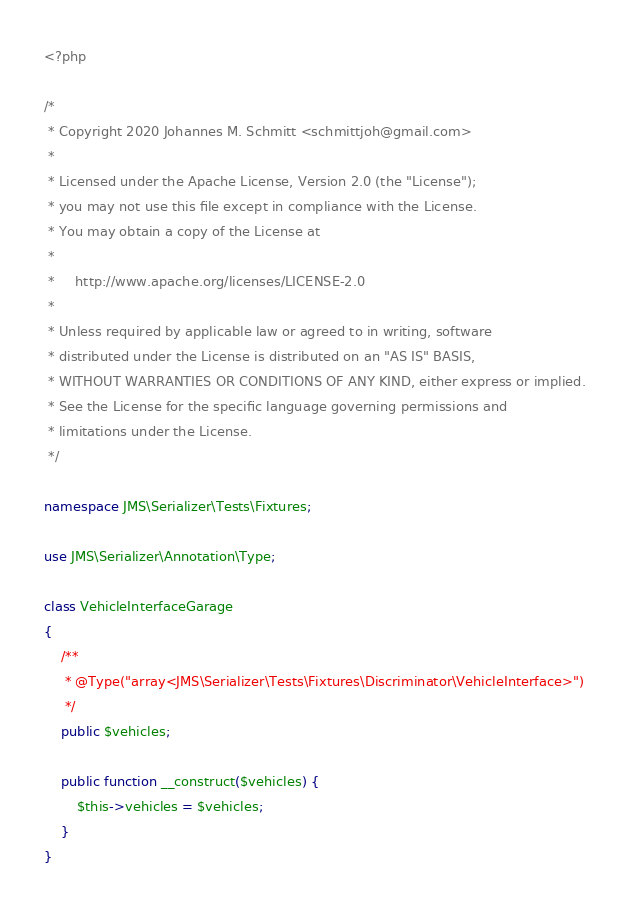Convert code to text. <code><loc_0><loc_0><loc_500><loc_500><_PHP_><?php

/*
 * Copyright 2020 Johannes M. Schmitt <schmittjoh@gmail.com>
 *
 * Licensed under the Apache License, Version 2.0 (the "License");
 * you may not use this file except in compliance with the License.
 * You may obtain a copy of the License at
 *
 *     http://www.apache.org/licenses/LICENSE-2.0
 *
 * Unless required by applicable law or agreed to in writing, software
 * distributed under the License is distributed on an "AS IS" BASIS,
 * WITHOUT WARRANTIES OR CONDITIONS OF ANY KIND, either express or implied.
 * See the License for the specific language governing permissions and
 * limitations under the License.
 */

namespace JMS\Serializer\Tests\Fixtures;

use JMS\Serializer\Annotation\Type;

class VehicleInterfaceGarage
{
    /**
     * @Type("array<JMS\Serializer\Tests\Fixtures\Discriminator\VehicleInterface>")
     */
    public $vehicles;

    public function __construct($vehicles) {
        $this->vehicles = $vehicles;
    }
}
</code> 